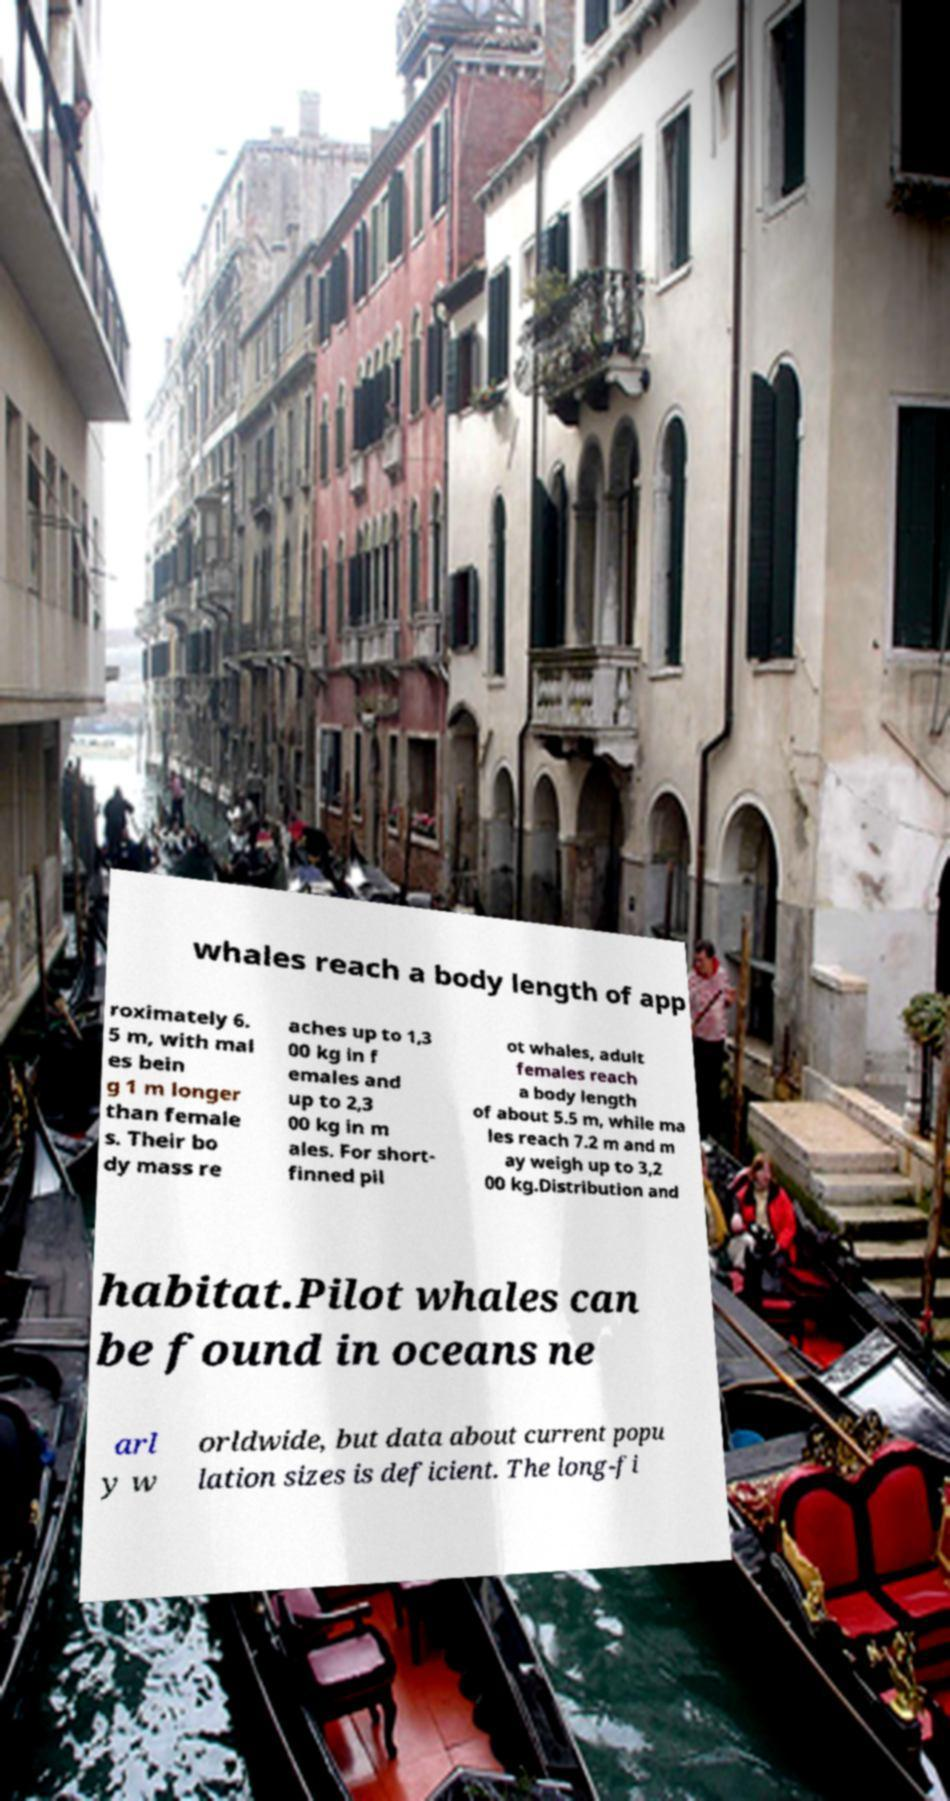I need the written content from this picture converted into text. Can you do that? whales reach a body length of app roximately 6. 5 m, with mal es bein g 1 m longer than female s. Their bo dy mass re aches up to 1,3 00 kg in f emales and up to 2,3 00 kg in m ales. For short- finned pil ot whales, adult females reach a body length of about 5.5 m, while ma les reach 7.2 m and m ay weigh up to 3,2 00 kg.Distribution and habitat.Pilot whales can be found in oceans ne arl y w orldwide, but data about current popu lation sizes is deficient. The long-fi 